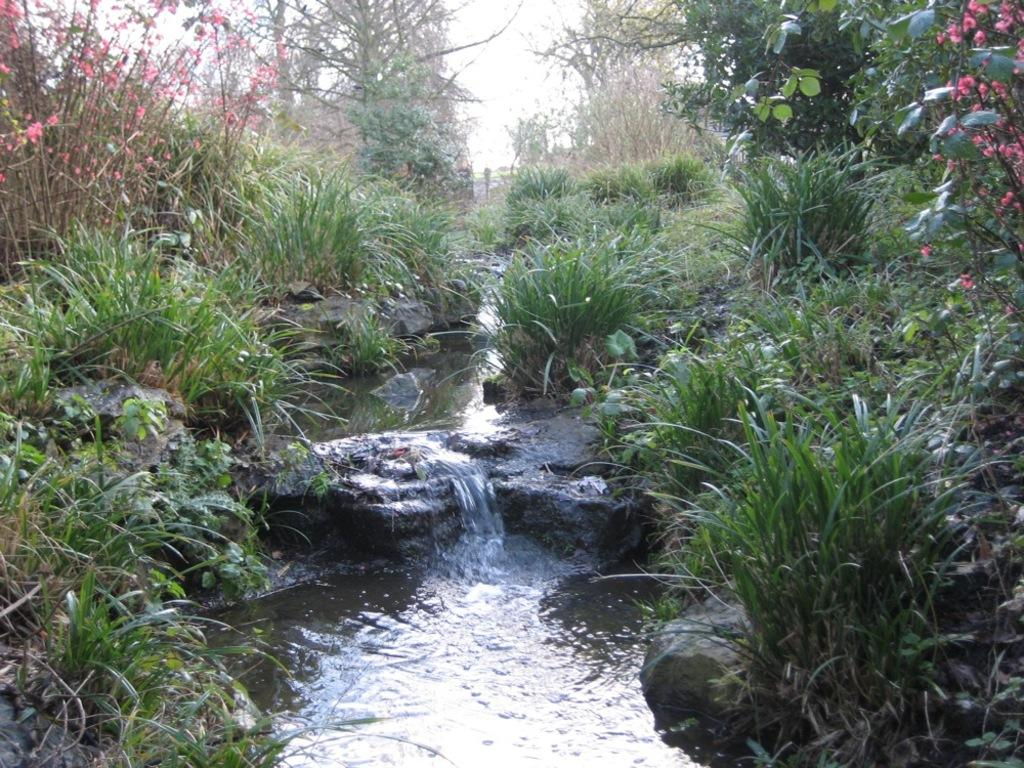What natural feature is present in the image? There is a small waterfall in the image. What can be seen behind the waterfall? There are plants and trees behind the waterfall. What type of mitten is being used to control the flow of the waterfall in the image? There is no mitten present in the image, and no one is controlling the flow of the waterfall. 